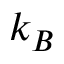<formula> <loc_0><loc_0><loc_500><loc_500>k _ { B }</formula> 